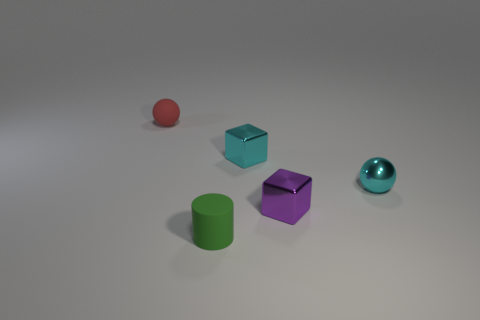Subtract all gray cubes. Subtract all blue cylinders. How many cubes are left? 2 Add 5 tiny metallic cubes. How many objects exist? 10 Subtract all blocks. How many objects are left? 3 Add 3 tiny red objects. How many tiny red objects are left? 4 Add 2 tiny spheres. How many tiny spheres exist? 4 Subtract 0 blue blocks. How many objects are left? 5 Subtract all small things. Subtract all big yellow balls. How many objects are left? 0 